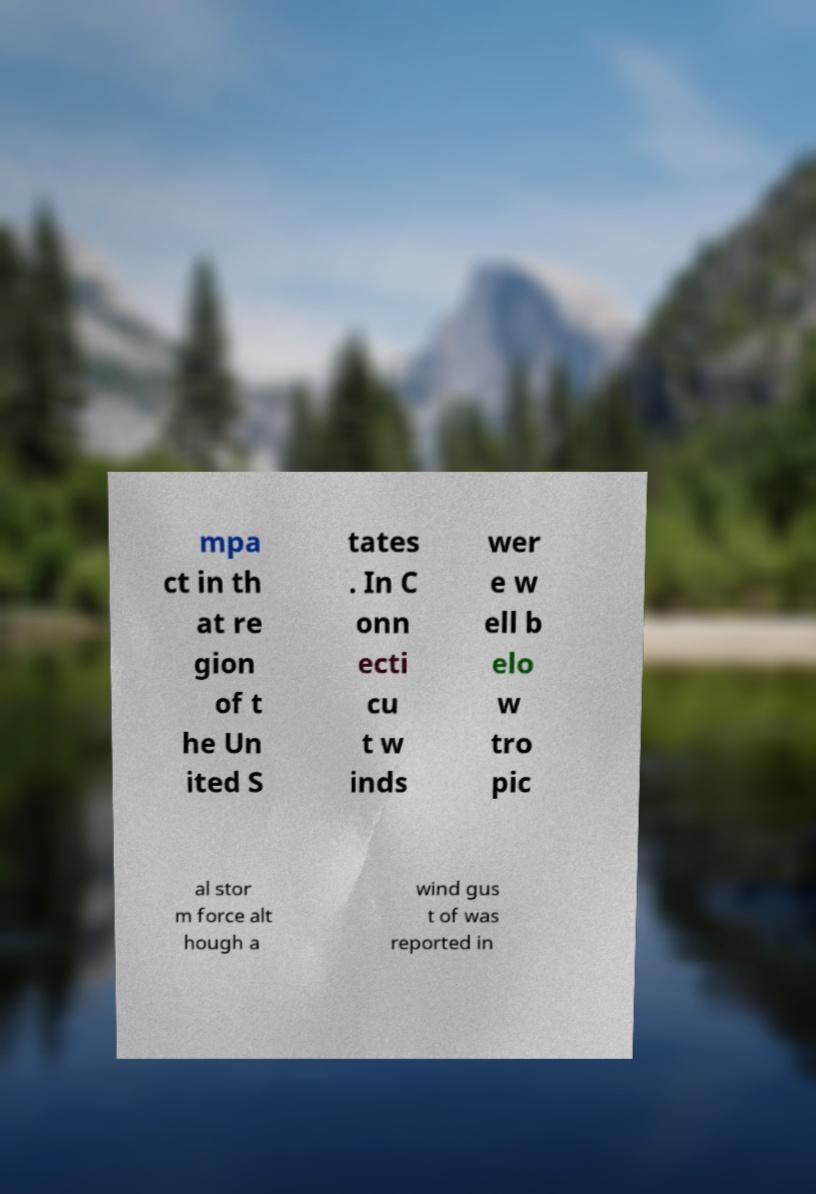What messages or text are displayed in this image? I need them in a readable, typed format. mpa ct in th at re gion of t he Un ited S tates . In C onn ecti cu t w inds wer e w ell b elo w tro pic al stor m force alt hough a wind gus t of was reported in 